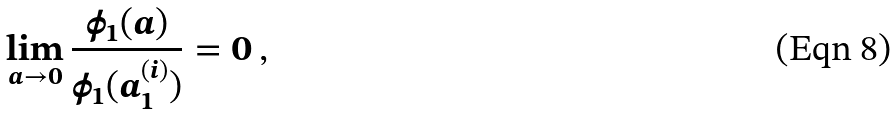Convert formula to latex. <formula><loc_0><loc_0><loc_500><loc_500>\lim _ { a \to 0 } \frac { \phi _ { 1 } ( a ) } { \phi _ { 1 } ( a ^ { ( i ) } _ { 1 } ) } = 0 \, ,</formula> 